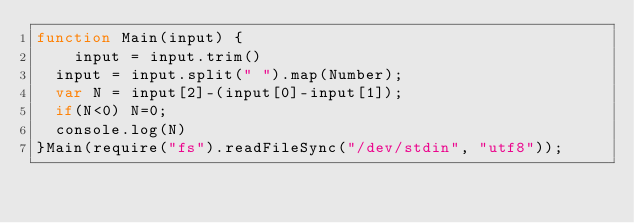<code> <loc_0><loc_0><loc_500><loc_500><_JavaScript_>function Main(input) {
    input = input.trim()
  input = input.split(" ").map(Number);
  var N = input[2]-(input[0]-input[1]);
  if(N<0) N=0;
  console.log(N)
}Main(require("fs").readFileSync("/dev/stdin", "utf8"));
</code> 